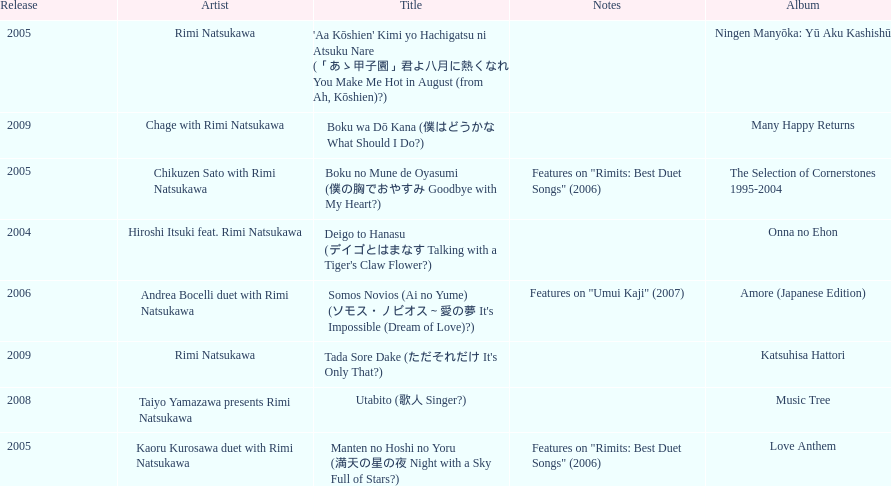Which title has the same notes as night with a sky full of stars? Boku no Mune de Oyasumi (僕の胸でおやすみ Goodbye with My Heart?). 